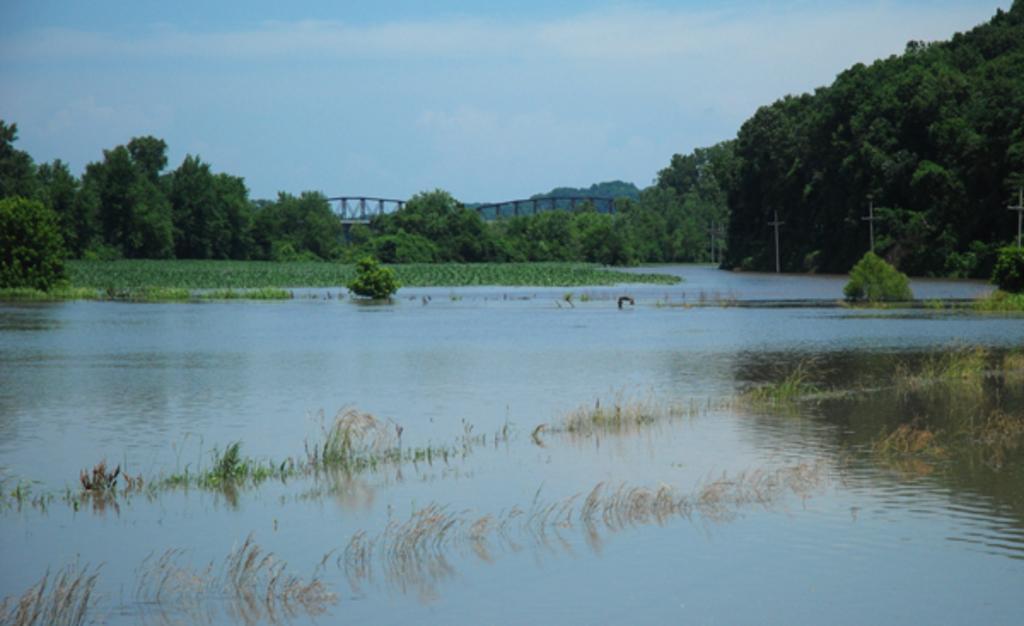Can you describe this image briefly? At the bottom of the image there is water. In the background there are some trees, bridge and sky. 